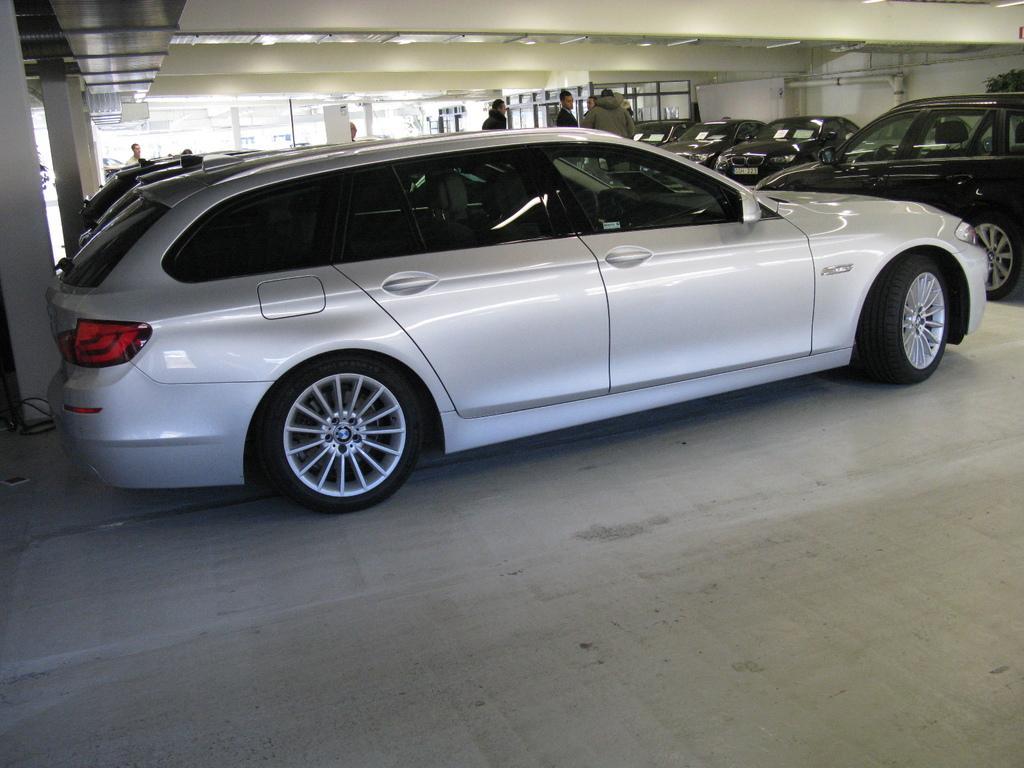How would you summarize this image in a sentence or two? In the foreground of this image, there are cars and persons in the basement of a building. 